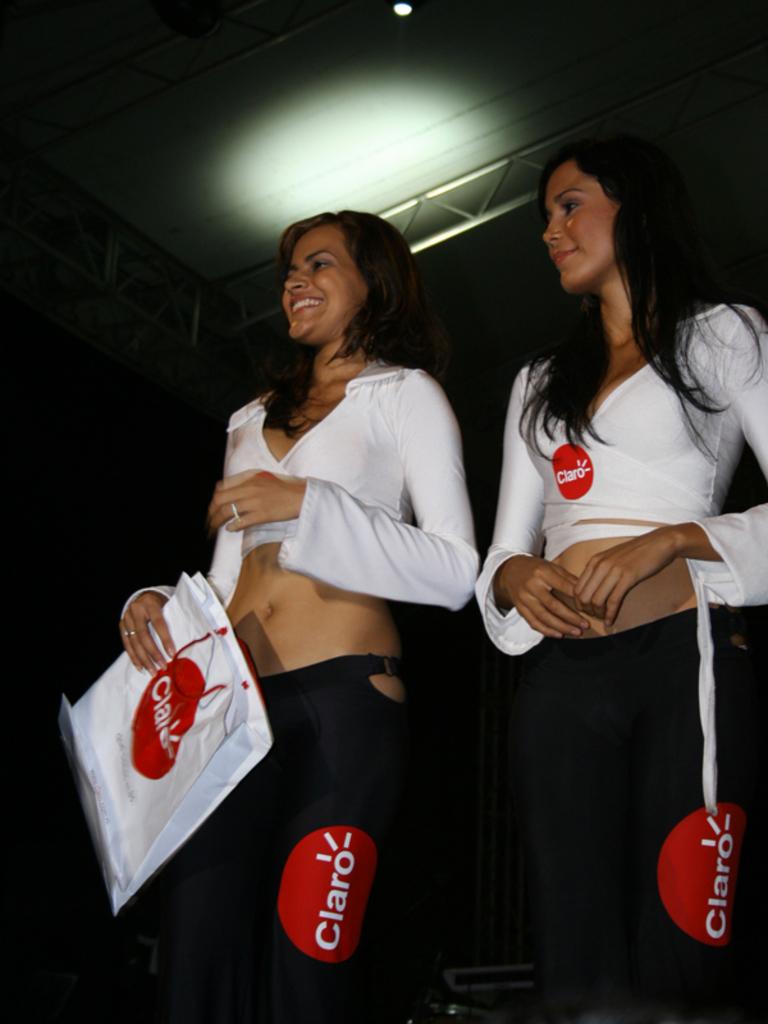What brand is being advertised?
Ensure brevity in your answer.  Claro. 